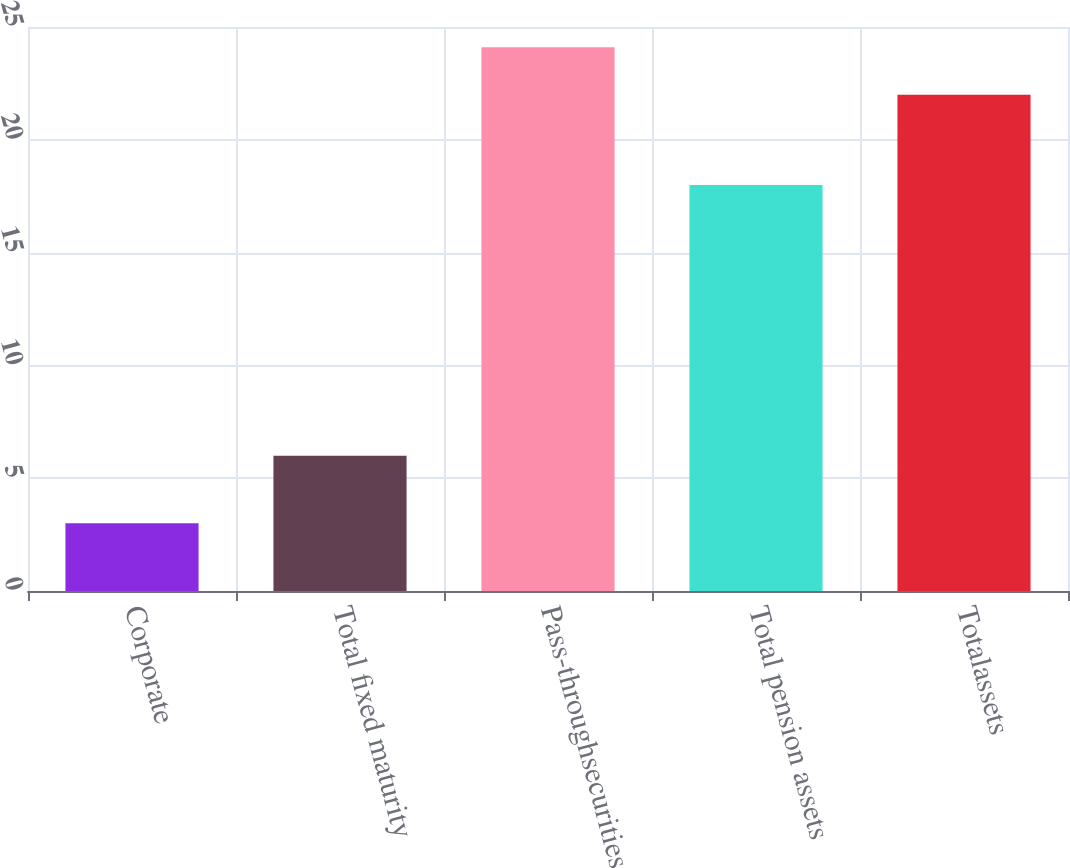<chart> <loc_0><loc_0><loc_500><loc_500><bar_chart><fcel>Corporate<fcel>Total fixed maturity<fcel>Pass-throughsecurities<fcel>Total pension assets<fcel>Totalassets<nl><fcel>3<fcel>6<fcel>24.1<fcel>18<fcel>22<nl></chart> 